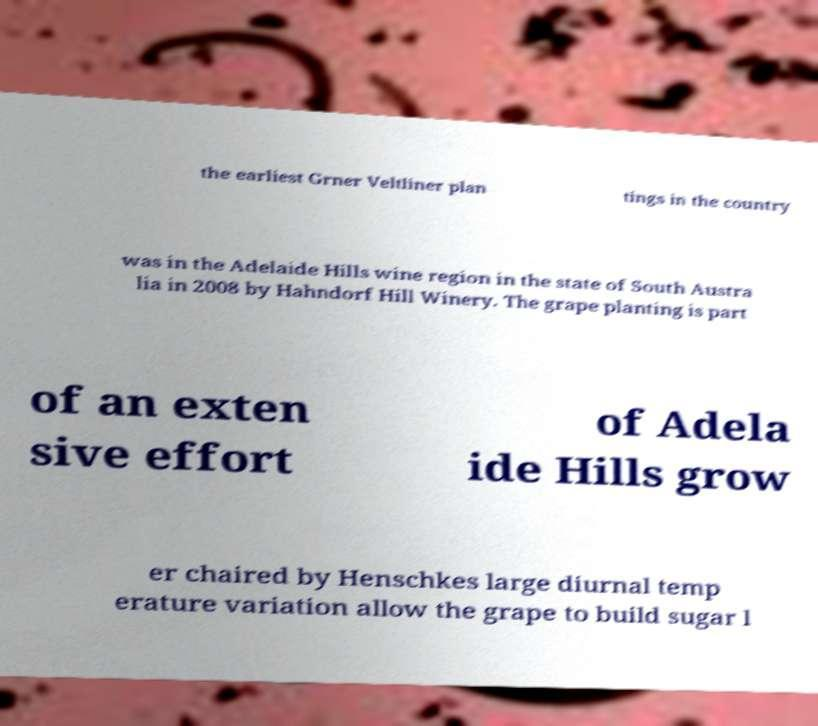Please identify and transcribe the text found in this image. the earliest Grner Veltliner plan tings in the country was in the Adelaide Hills wine region in the state of South Austra lia in 2008 by Hahndorf Hill Winery. The grape planting is part of an exten sive effort of Adela ide Hills grow er chaired by Henschkes large diurnal temp erature variation allow the grape to build sugar l 